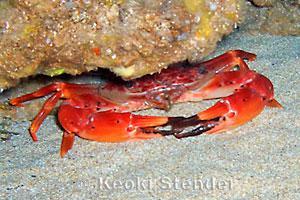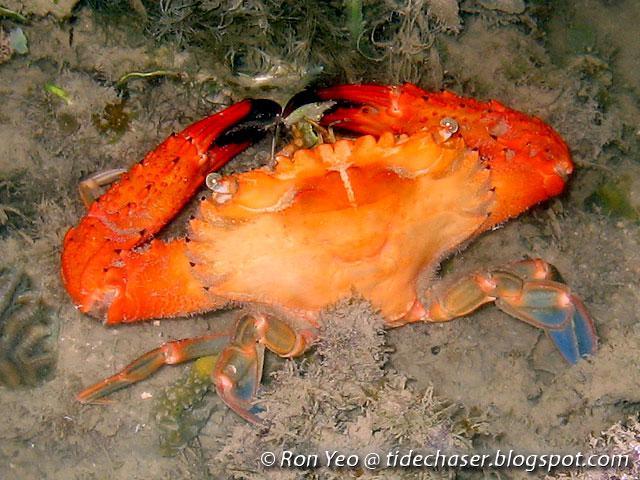The first image is the image on the left, the second image is the image on the right. For the images shown, is this caption "Each image shows a crab with its face toward the front instead of rear-facing, and all crabs are angled leftward." true? Answer yes or no. No. 